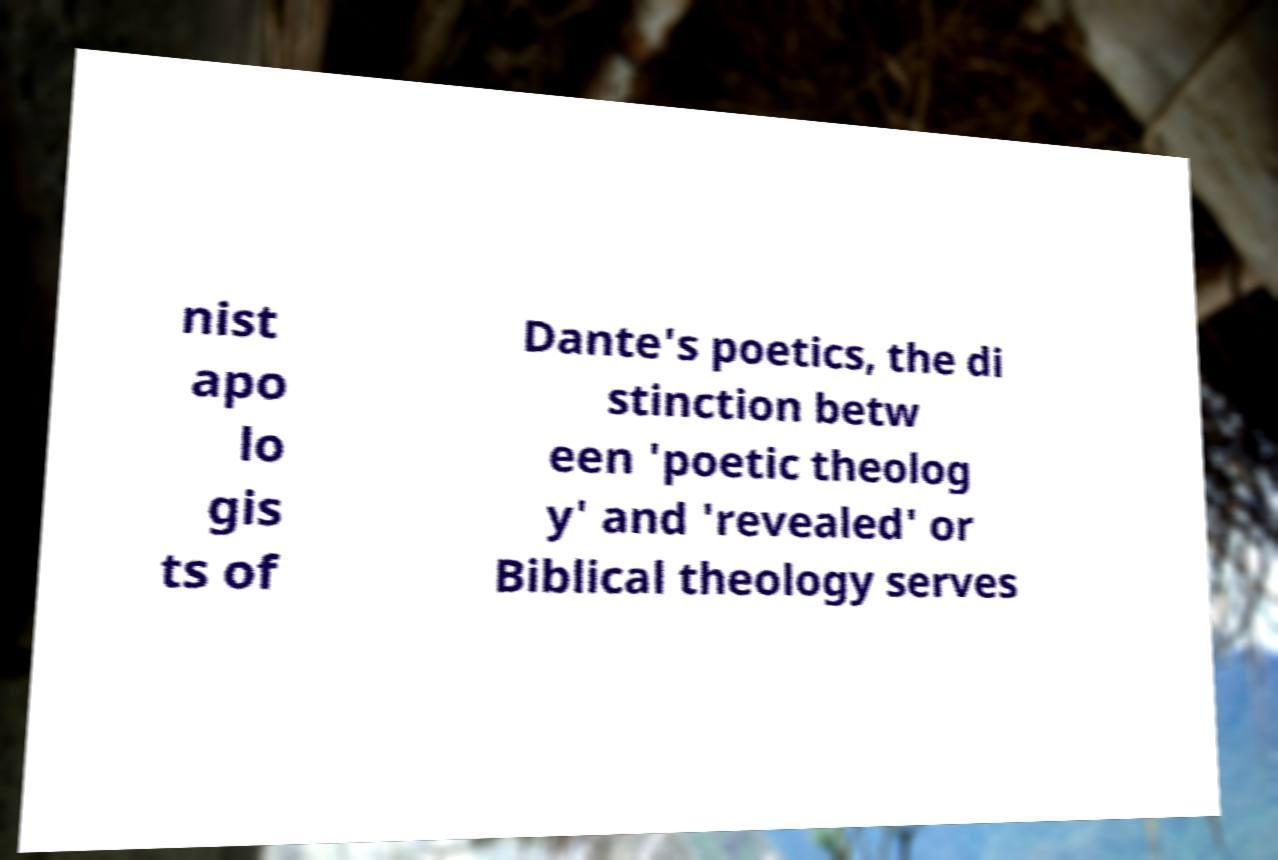Please read and relay the text visible in this image. What does it say? nist apo lo gis ts of Dante's poetics, the di stinction betw een 'poetic theolog y' and 'revealed' or Biblical theology serves 